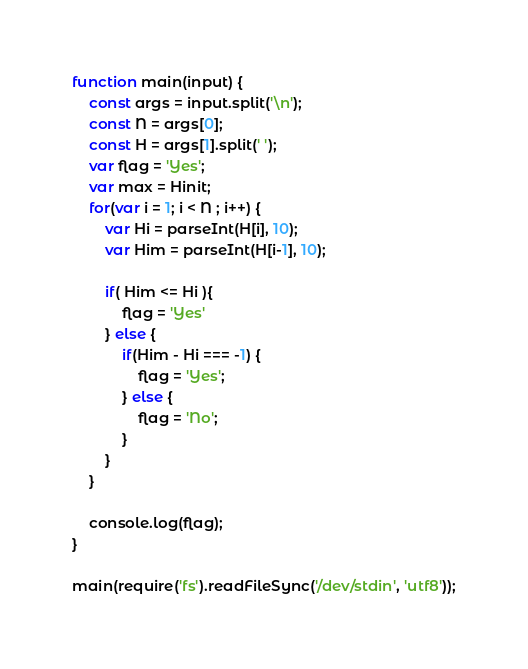<code> <loc_0><loc_0><loc_500><loc_500><_JavaScript_>function main(input) {
    const args = input.split('\n');
    const N = args[0];
    const H = args[1].split(' ');
    var flag = 'Yes';
    var max = Hinit;
    for(var i = 1; i < N ; i++) {
        var Hi = parseInt(H[i], 10);
        var Him = parseInt(H[i-1], 10);

        if( Him <= Hi ){
            flag = 'Yes'
        } else {
            if(Him - Hi === -1) {
                flag = 'Yes';
            } else {
                flag = 'No';
            }
        }
    }

    console.log(flag);
}

main(require('fs').readFileSync('/dev/stdin', 'utf8'));</code> 